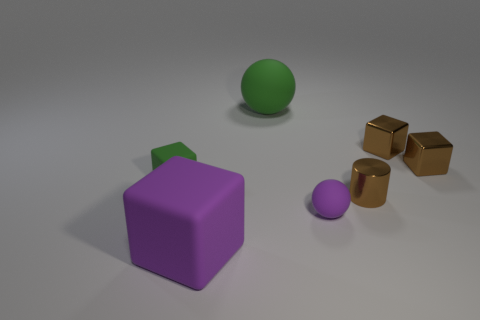What number of other objects are the same color as the big matte ball?
Make the answer very short. 1. Are there any big red metallic spheres?
Your answer should be compact. No. What is the color of the matte block behind the tiny matte sphere?
Ensure brevity in your answer.  Green. There is a big rubber object that is behind the big rubber object in front of the tiny green thing; how many balls are right of it?
Your answer should be compact. 1. The object that is left of the purple ball and in front of the small green matte cube is made of what material?
Your answer should be very brief. Rubber. Is the tiny green object made of the same material as the green object behind the green rubber cube?
Provide a succinct answer. Yes. Is the number of cubes that are to the right of the small brown shiny cylinder greater than the number of spheres behind the big green object?
Offer a very short reply. Yes. There is a big purple object; what shape is it?
Give a very brief answer. Cube. Is the material of the large green object that is right of the big matte cube the same as the thing that is to the left of the large purple object?
Your response must be concise. Yes. The small rubber thing that is on the right side of the green rubber block has what shape?
Make the answer very short. Sphere. 